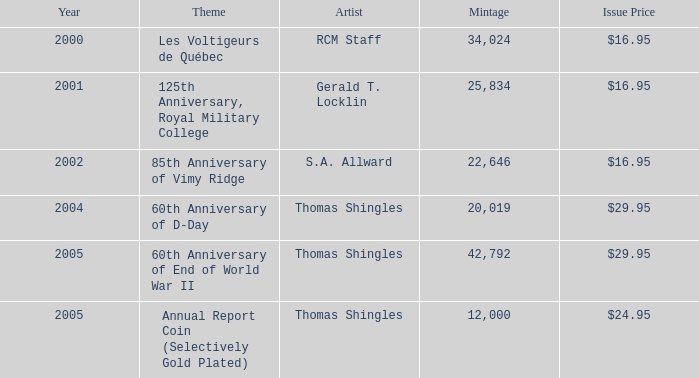What was the complete minting for years post-2002 featuring an 85th anniversary of vimy ridge theme? 0.0. 